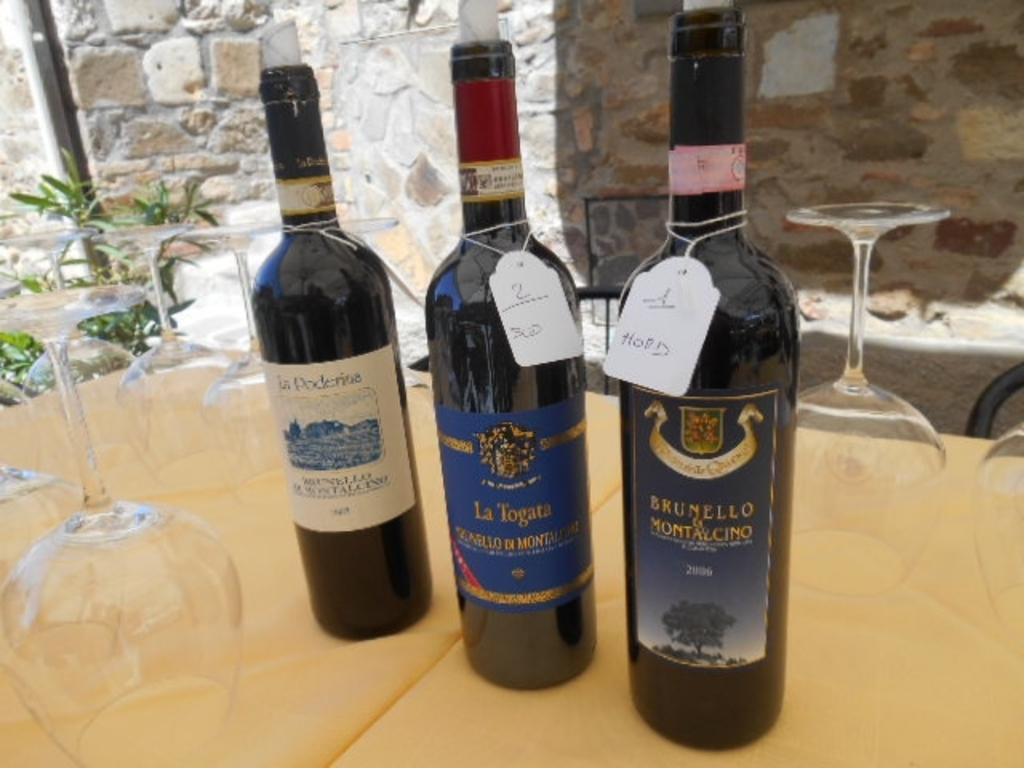What type of furniture is present in the image? There is a table in the image. What objects are placed on the table? There are glasses and bottles on the table. What can be seen in the background of the image? There is a wall in the background of the image. What is located on the left side of the image? There is a plant on the left side of the image. What day of the week is depicted in the image? The day of the week is not depicted in the image, as it is a still image and does not show any time-related information. 